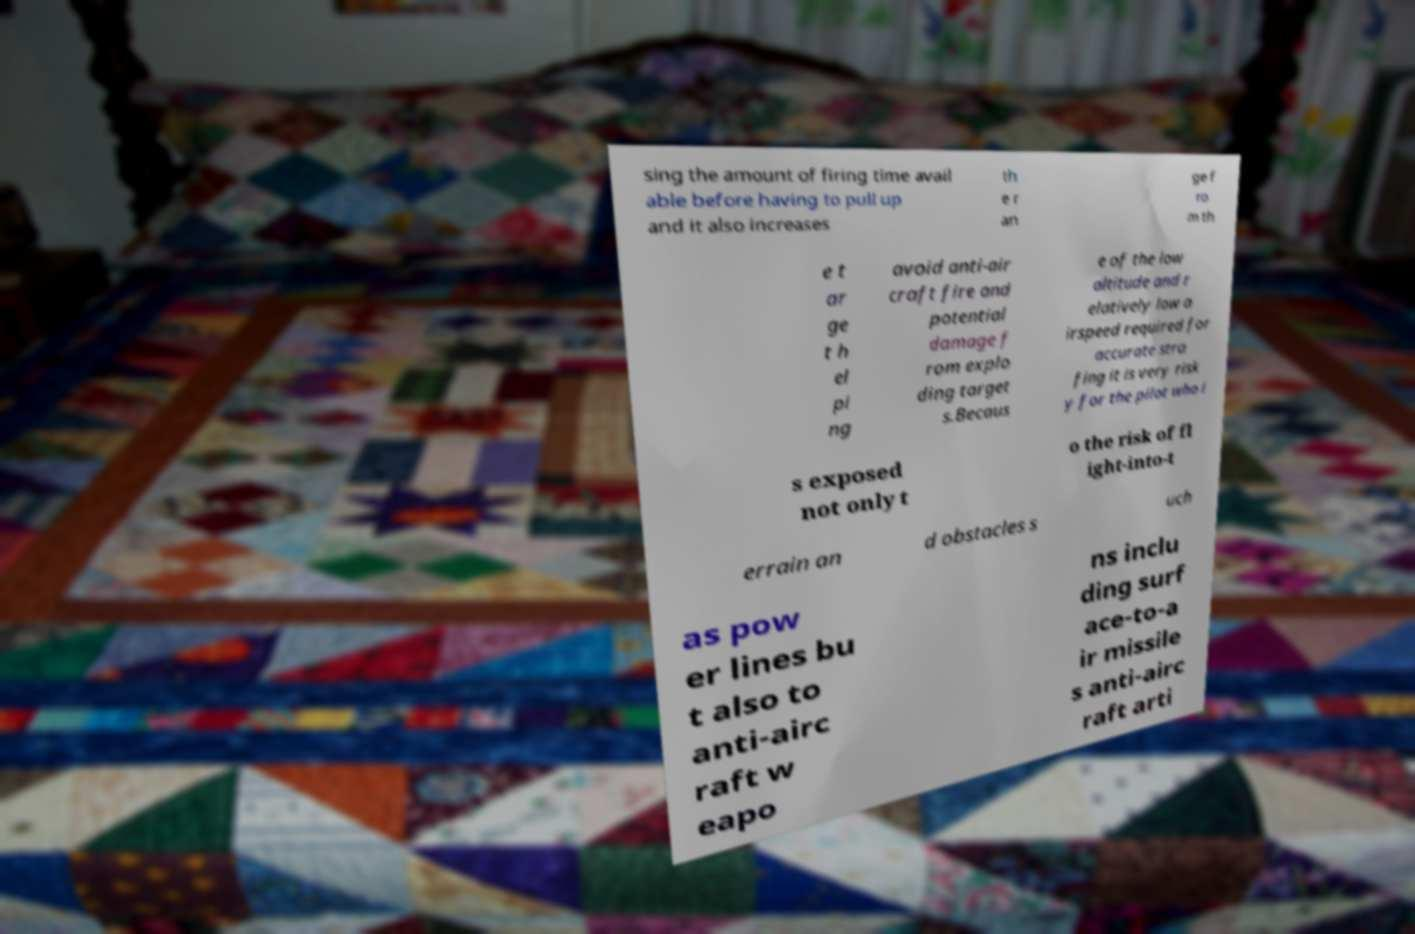Please read and relay the text visible in this image. What does it say? sing the amount of firing time avail able before having to pull up and it also increases th e r an ge f ro m th e t ar ge t h el pi ng avoid anti-air craft fire and potential damage f rom explo ding target s.Becaus e of the low altitude and r elatively low a irspeed required for accurate stra fing it is very risk y for the pilot who i s exposed not only t o the risk of fl ight-into-t errain an d obstacles s uch as pow er lines bu t also to anti-airc raft w eapo ns inclu ding surf ace-to-a ir missile s anti-airc raft arti 